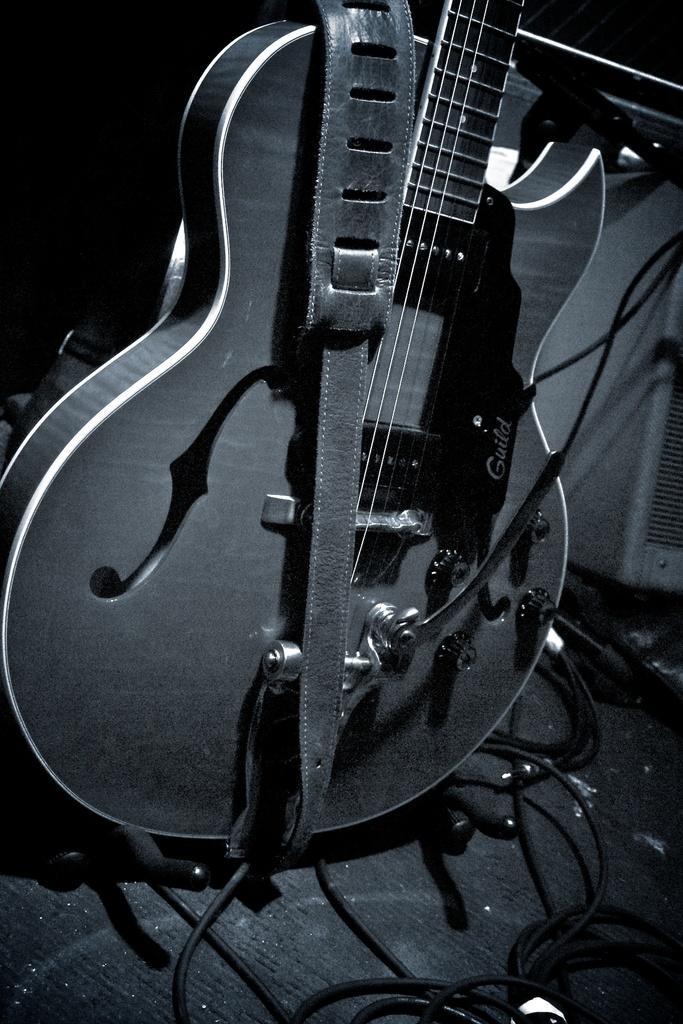How would you summarize this image in a sentence or two? In the picture there is a guitar and its strap. In the foreground there are cables. On the right there is another object. 